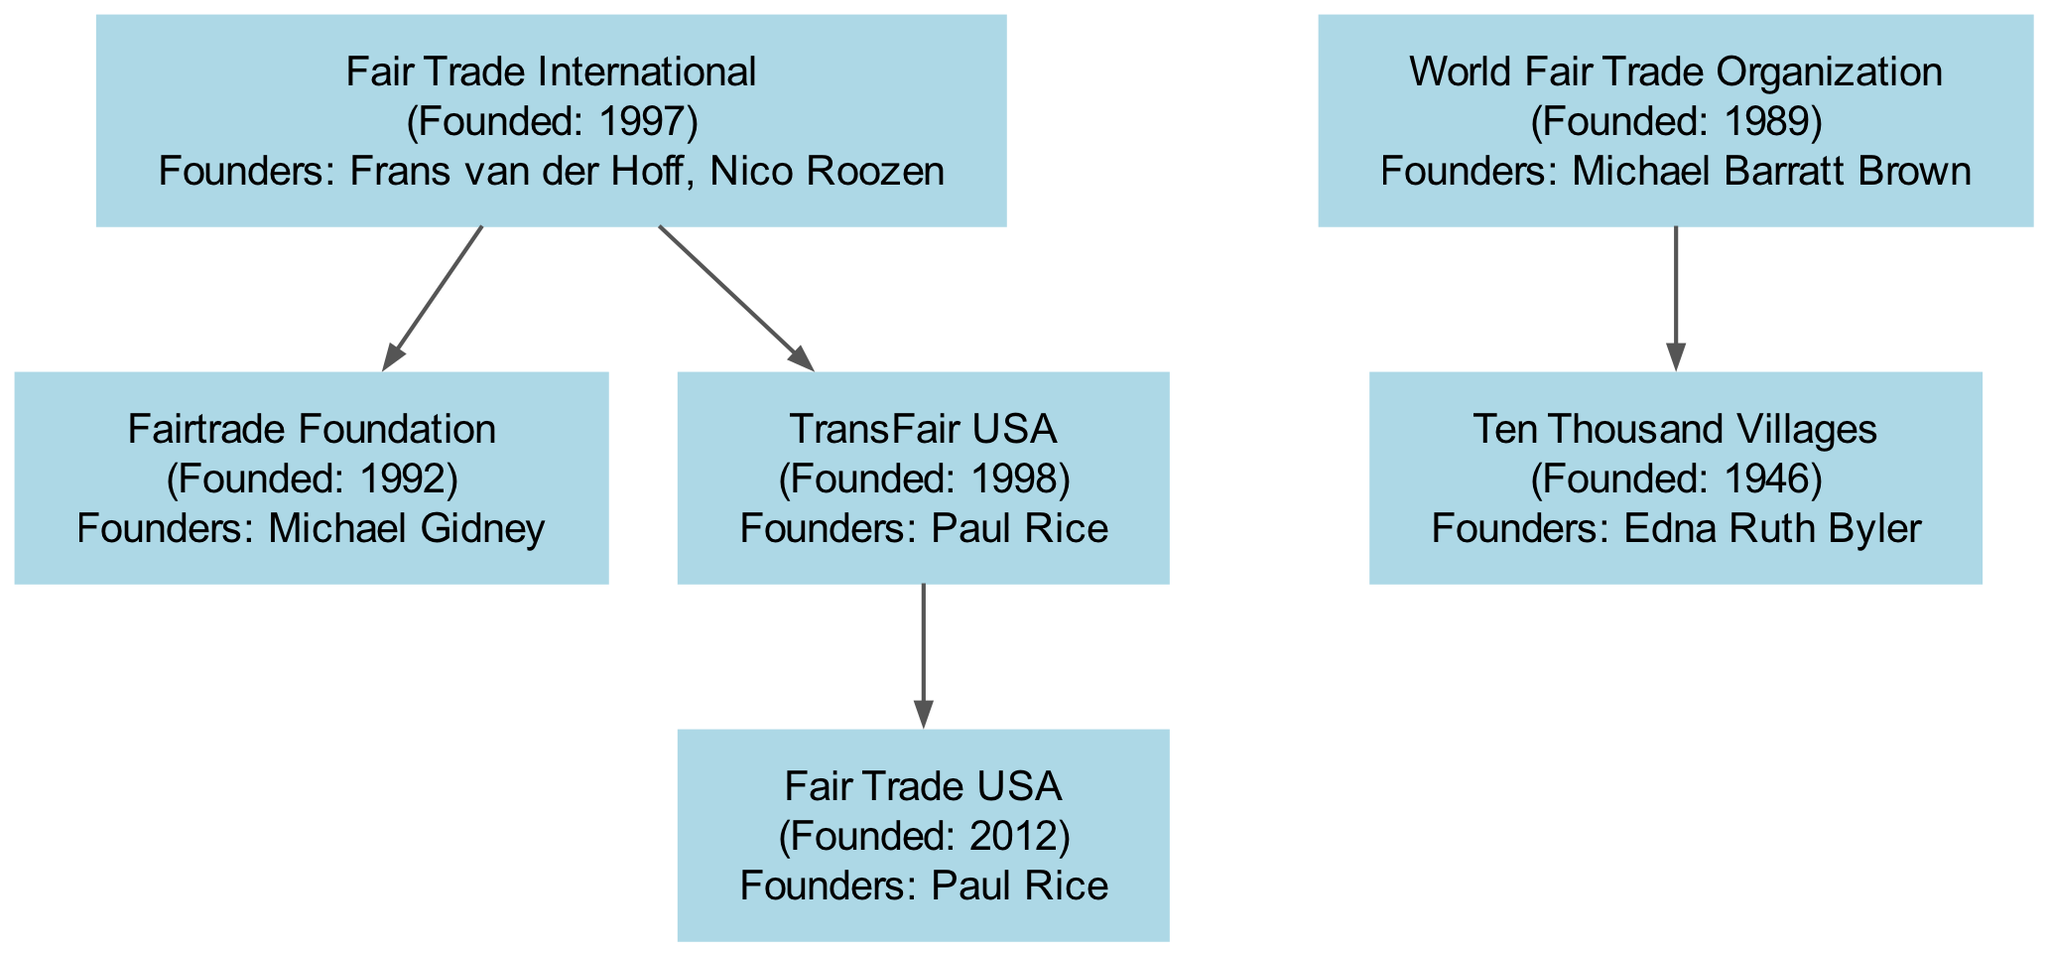What year was Fair Trade International founded? To find the answer, locate the node for Fair Trade International and check the founding year mentioned in the label. The diagram shows it was founded in 1997.
Answer: 1997 Who is the founder of Fair Trade USA? Look at the Fair Trade USA node in the diagram, which lists the founders. It shows that Paul Rice is the only founder mentioned there.
Answer: Paul Rice What organization does Fairtrade Foundation belong to? Investigate the relationship between Fairtrade Foundation and its parent organization in the diagram. It's clear that Fairtrade Foundation is a child organization of Fair Trade International.
Answer: Fair Trade International How many organizations were founded in the 1990s? Review all the nodes and their founding years. Fair Trade International (1997), Fairtrade Foundation (1992), and World Fair Trade Organization (1989) all fall within the 1990s, totaling three organizations.
Answer: 3 Which organization was established first? Scan through the founding years of all organizations presented in the diagram. Ten Thousand Villages was founded in 1946, making it the earliest organization in the tree.
Answer: Ten Thousand Villages What organization is a child of TransFair USA? Check the children of TransFair USA in the diagram. It indicates that Fair Trade USA is a child of TransFair USA.
Answer: Fair Trade USA Who founded Ten Thousand Villages? Locate the Ten Thousand Villages node and read the founder's name listed in the label. Edna Ruth Byler is indicated as the founder here.
Answer: Edna Ruth Byler What is the relationship between Fair Trade USA and TransFair USA? Analyze the diagram's node for their connection. Fair Trade USA is a child organization of TransFair USA, meaning it was developed as a subsequent entity.
Answer: Child organization How many total nodes are displayed in the diagram? Count the total entities represented in the diagram. There are seven organizations shown as nodes, including parent and child relationships.
Answer: 7 